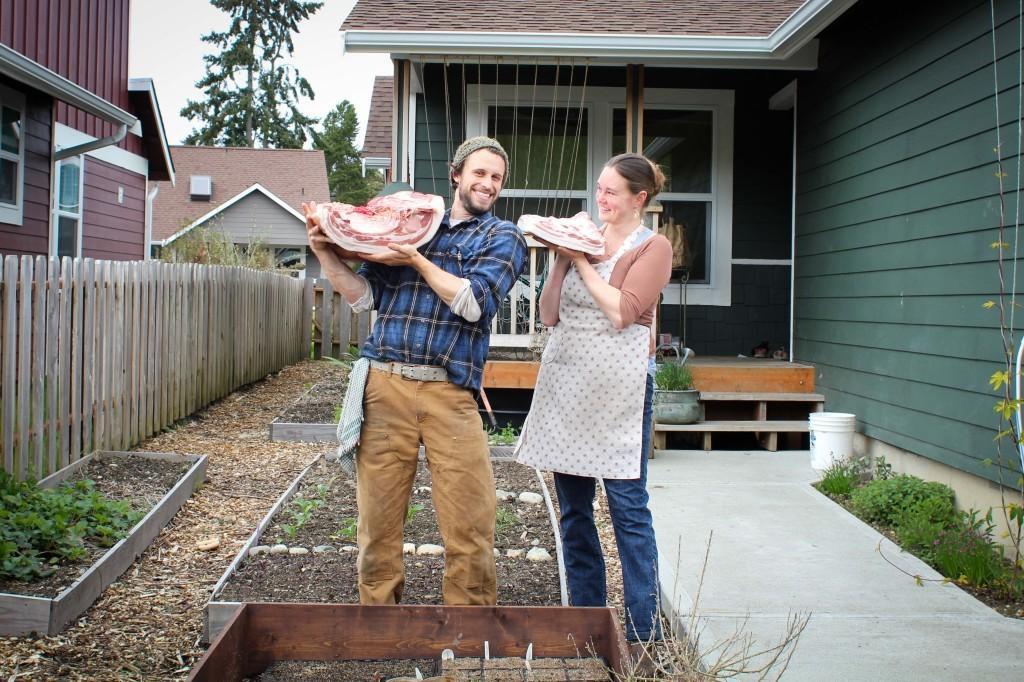Describe this image in one or two sentences. In the center of the image we can see two persons are standing and smiling and holding the meat. In the background of the image we can see the buildings, roof, trees, windows, wall, fencing, plants, pot, bucket. At the bottom of the image we can see the ground. 